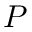Convert formula to latex. <formula><loc_0><loc_0><loc_500><loc_500>P</formula> 